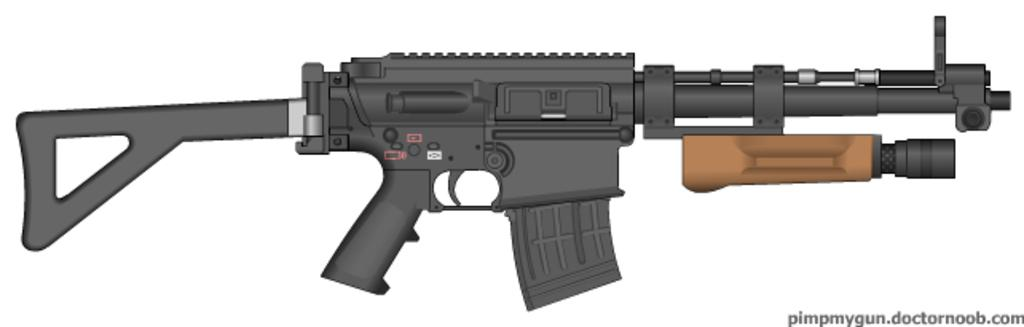What type of image is being described? The image is animated. What object can be seen in the image? There is a rifle in the image. What colors are used for the rifle? The rifle is dark gray and brown in color. Is there any additional information or marking in the image? Yes, there is a watermark in the right bottom corner of the image. What type of loaf is being sliced with the knife in the image? There is no loaf or knife present in the image; it features an animated rifle. 